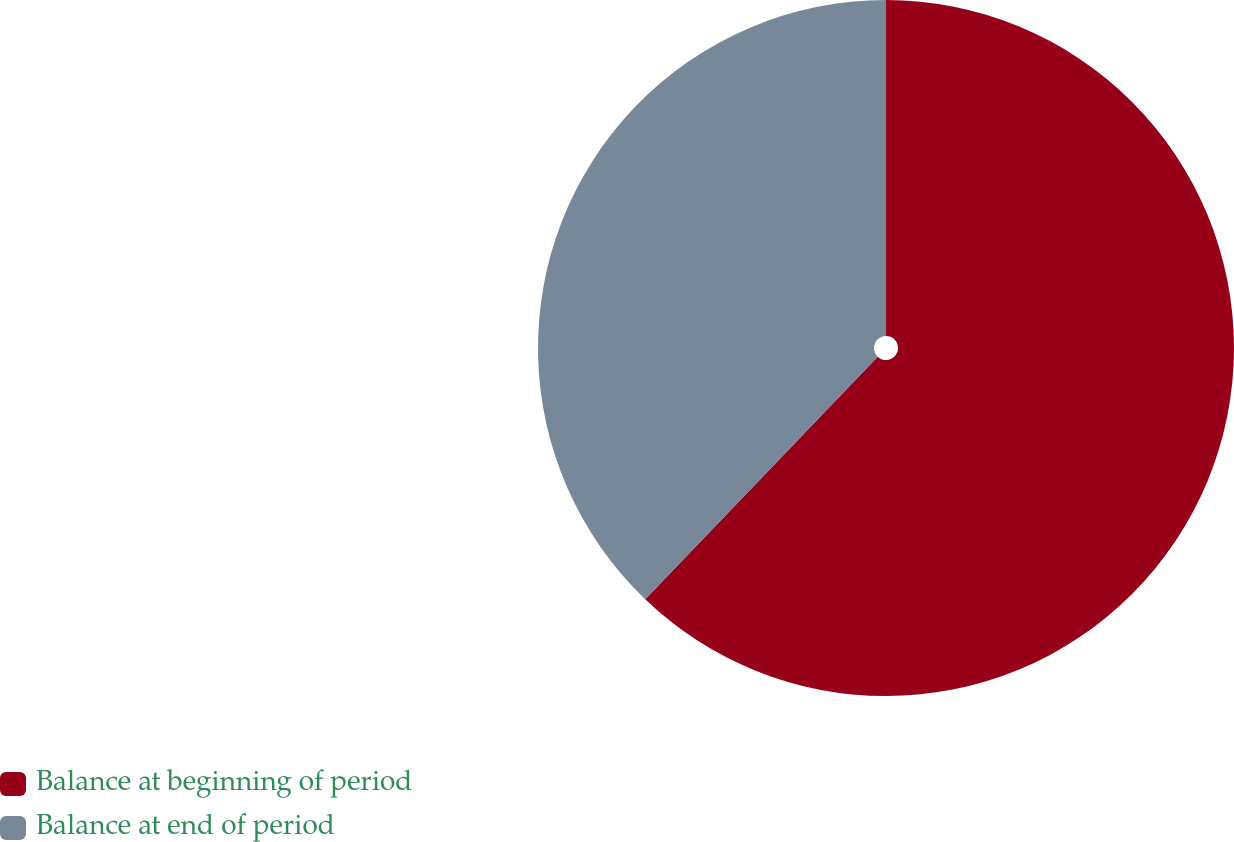Convert chart to OTSL. <chart><loc_0><loc_0><loc_500><loc_500><pie_chart><fcel>Balance at beginning of period<fcel>Balance at end of period<nl><fcel>62.16%<fcel>37.84%<nl></chart> 